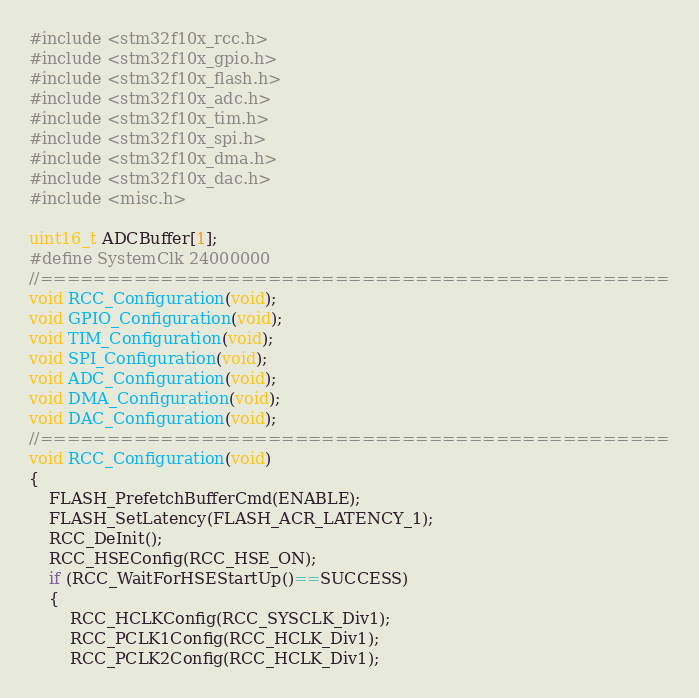<code> <loc_0><loc_0><loc_500><loc_500><_C_>
#include <stm32f10x_rcc.h>
#include <stm32f10x_gpio.h>
#include <stm32f10x_flash.h>
#include <stm32f10x_adc.h>
#include <stm32f10x_tim.h>
#include <stm32f10x_spi.h>
#include <stm32f10x_dma.h>
#include <stm32f10x_dac.h>
#include <misc.h>

uint16_t ADCBuffer[1];
#define SystemClk 24000000
//===============================================
void RCC_Configuration(void);
void GPIO_Configuration(void);
void TIM_Configuration(void);
void SPI_Configuration(void);
void ADC_Configuration(void);
void DMA_Configuration(void);
void DAC_Configuration(void);
//===============================================
void RCC_Configuration(void)
{
	FLASH_PrefetchBufferCmd(ENABLE);
	FLASH_SetLatency(FLASH_ACR_LATENCY_1);
    RCC_DeInit();
    RCC_HSEConfig(RCC_HSE_ON);
    if (RCC_WaitForHSEStartUp()==SUCCESS)
    {
    	RCC_HCLKConfig(RCC_SYSCLK_Div1);
    	RCC_PCLK1Config(RCC_HCLK_Div1);
    	RCC_PCLK2Config(RCC_HCLK_Div1);</code> 